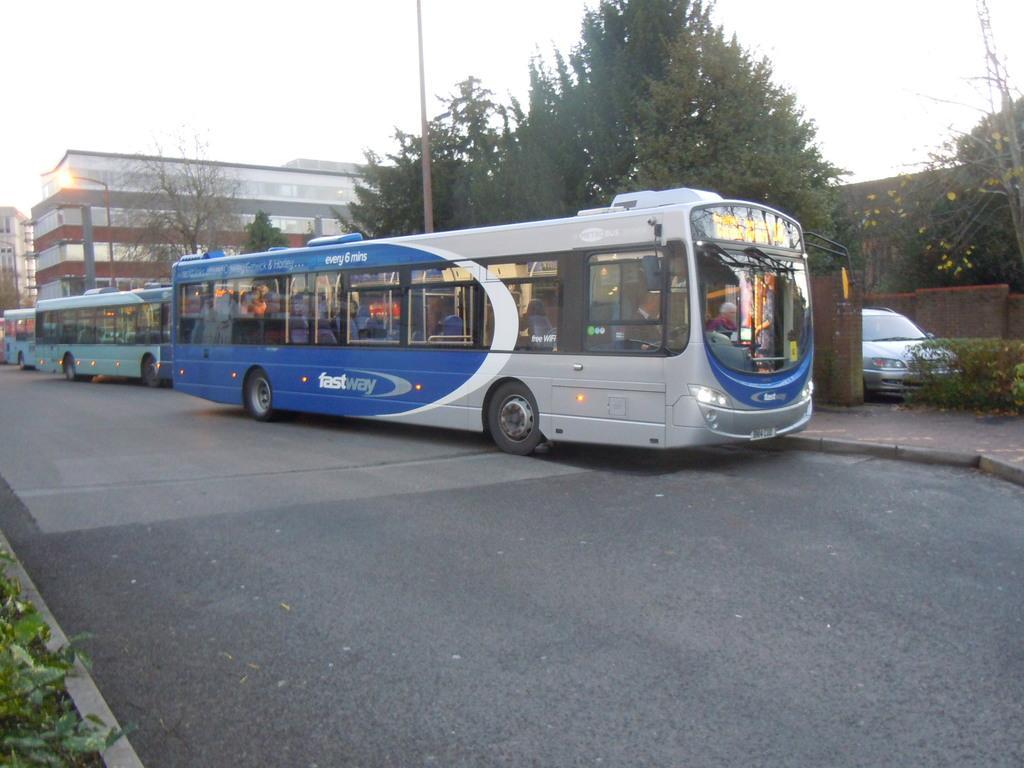Can you describe this image briefly? Here we can see a person riding a bus on the road. In the background there are vehicles,buildings,poles,windows,trees,a car at the fence and sky. On the left at the bottom corner there is a plant. 